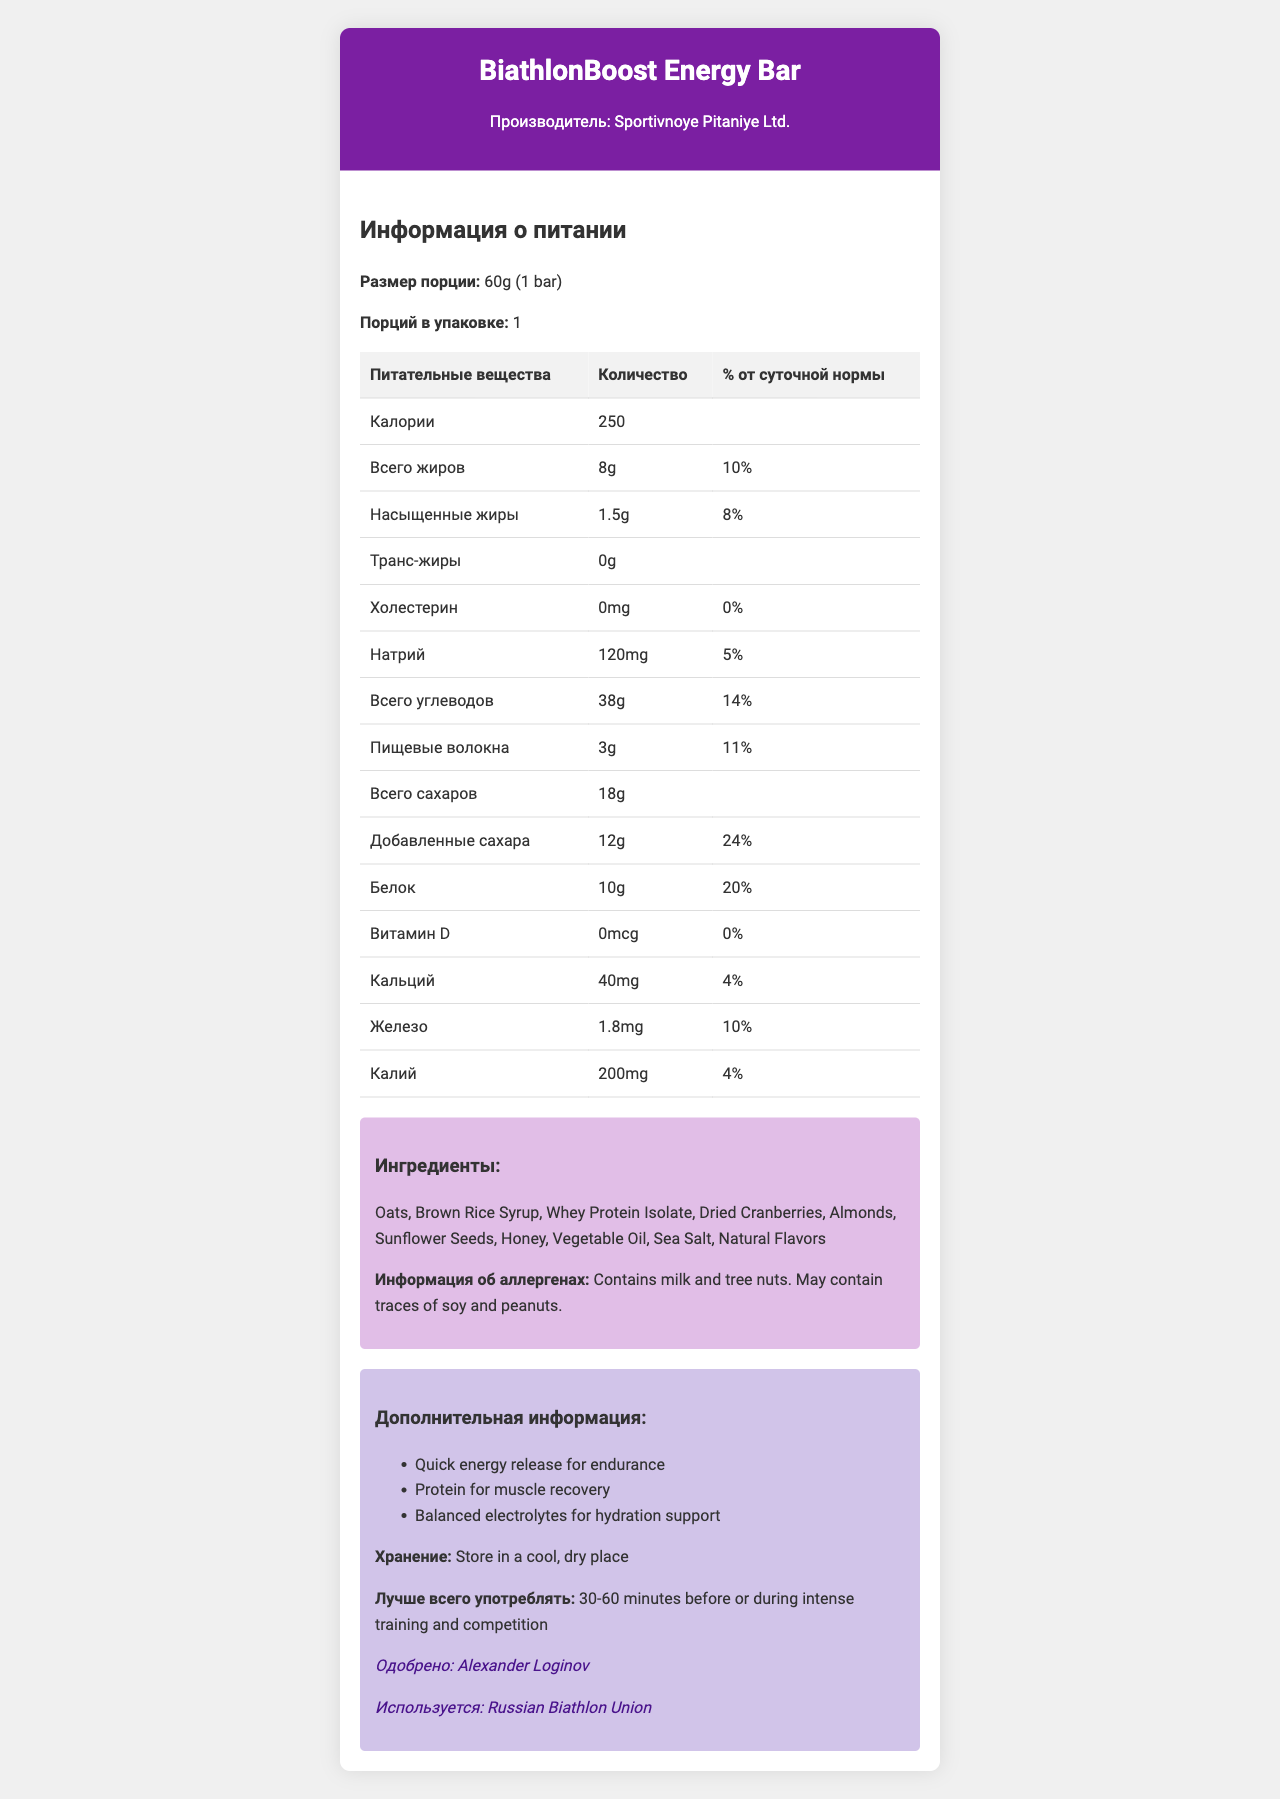What is the serving size of the BiathlonBoost Energy Bar? The serving size is clearly stated as "60g (1 bar)" in the Nutrition Facts Label.
Answer: 60g (1 bar) Who is the manufacturer of the BiathlonBoost Energy Bar? The document specifies that the manufacturer is "Sportivnoye Pitaniye Ltd." just below the product name.
Answer: Sportivnoye Pitaniye Ltd. How many calories are in one bar? The document lists "250" under the calories section for one serving size, which is one bar.
Answer: 250 What is the total fat content per serving? The Nutrition Facts Label states the total fat amount as "8g."
Answer: 8g What is the daily value percentage for protein in the bar? The percentage daily value for protein is listed as "20%" in the table.
Answer: 20% What is the amount of dietary fiber in the BiathlonBoost Energy Bar? A. 1g B. 3g C. 5g D. 8g According to the Nutrition Facts Label, the dietary fiber content is "3g."
Answer: B Which of the following is NOT an ingredient in the BiathlonBoost Energy Bar? A. Oats B. Brown Rice Syrup C. Peanuts D. Dried Cranberries Peanuts are listed only as a potential allergen, not a direct ingredient, whereas the others are direct ingredients.
Answer: C Does the BiathlonBoost Energy Bar contain any cholesterol? The document shows "0mg" cholesterol content with a daily value of "0%."
Answer: No Summarize the key benefits of consuming the BiathlonBoost Energy Bar. The additional info section lists three key benefits: quick energy release, protein for muscle recovery, and balanced electrolytes for hydration.
Answer: Quick energy release for endurance, Protein for muscle recovery, Balanced electrolytes for hydration support Is there any Trans Fat in the BiathlonBoost Energy Bar? The Nutrition Facts Label specifies the trans fat content as "0g."
Answer: No Who endorses the BiathlonBoost Energy Bar? The additional information section notes that the bar is endorsed by Alexander Loginov.
Answer: Alexander Loginov Explain the allergen information for this product. The document clearly states that the bar contains milk and tree nuts and may contain traces of soy and peanuts in the ingredients and allergen info section.
Answer: Contains milk and tree nuts. May contain traces of soy and peanuts. Can this product be used by someone on a low-sodium diet? While the bar contains 120mg of sodium, whether this fits into a low-sodium diet can depend on the individual's specific dietary restrictions and medical advice, which is not provided here.
Answer: Not enough information Who uses the BiathlonBoost Energy Bar according to the document? The additional info notes that the bar is used by the "Russian Biathlon Union."
Answer: Russian Biathlon Union What is the best time to consume the BiathlonBoost Energy Bar for athletes? The document mentions that it is best consumed "30-60 minutes before or during intense training and competition."
Answer: 30-60 minutes before or during intense training and competition What is the storage recommendation for this product? The additional information on storage specifies "Store in a cool, dry place."
Answer: Store in a cool, dry place 